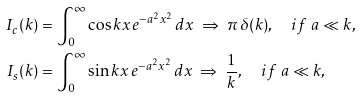Convert formula to latex. <formula><loc_0><loc_0><loc_500><loc_500>I _ { c } ( k ) & = \int _ { 0 } ^ { \infty } \cos k x \, e ^ { - a ^ { 2 } x ^ { 2 } } \, d x \ \Rightarrow \ \pi \, \delta ( k ) , \quad i f \ a \ll k , \\ I _ { s } ( k ) & = \int _ { 0 } ^ { \infty } \sin k x \, e ^ { - a ^ { 2 } x ^ { 2 } } \, d x \ \Rightarrow \ \frac { 1 } { k } , \quad i f \ a \ll k ,</formula> 